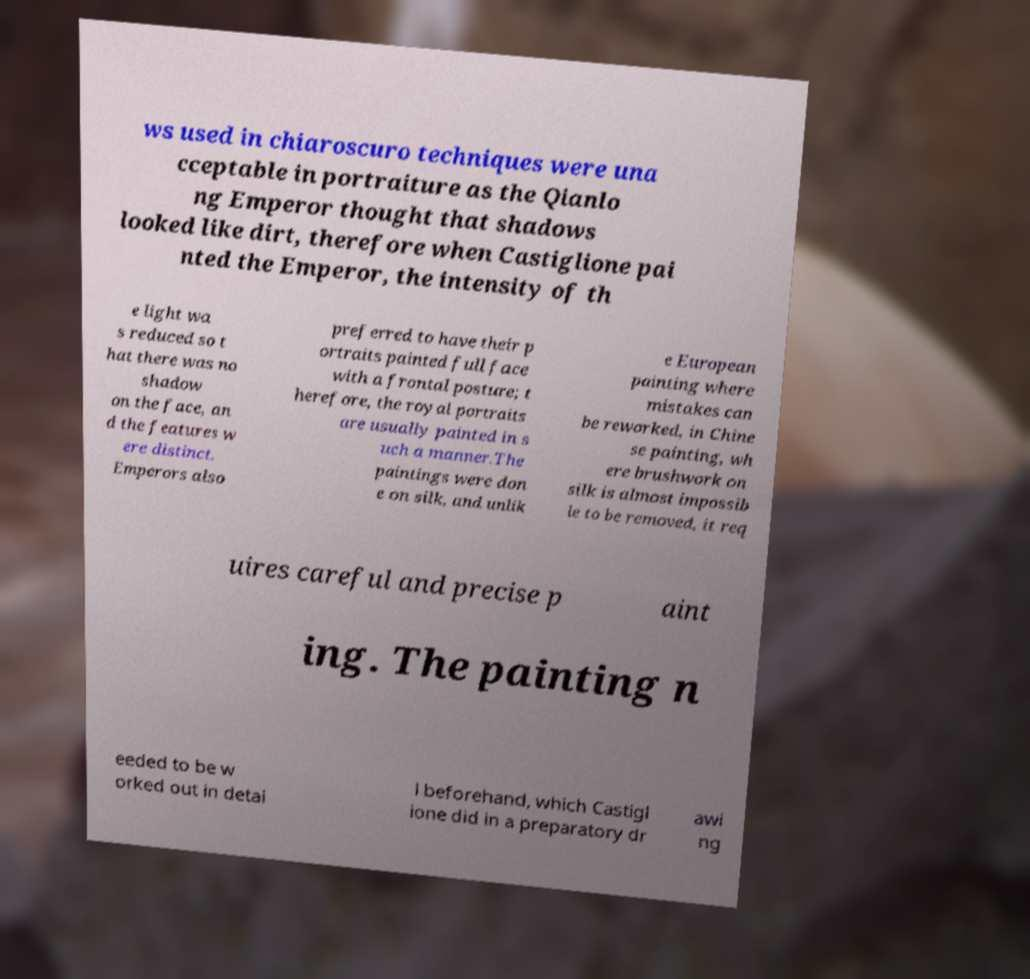There's text embedded in this image that I need extracted. Can you transcribe it verbatim? ws used in chiaroscuro techniques were una cceptable in portraiture as the Qianlo ng Emperor thought that shadows looked like dirt, therefore when Castiglione pai nted the Emperor, the intensity of th e light wa s reduced so t hat there was no shadow on the face, an d the features w ere distinct. Emperors also preferred to have their p ortraits painted full face with a frontal posture; t herefore, the royal portraits are usually painted in s uch a manner.The paintings were don e on silk, and unlik e European painting where mistakes can be reworked, in Chine se painting, wh ere brushwork on silk is almost impossib le to be removed, it req uires careful and precise p aint ing. The painting n eeded to be w orked out in detai l beforehand, which Castigl ione did in a preparatory dr awi ng 